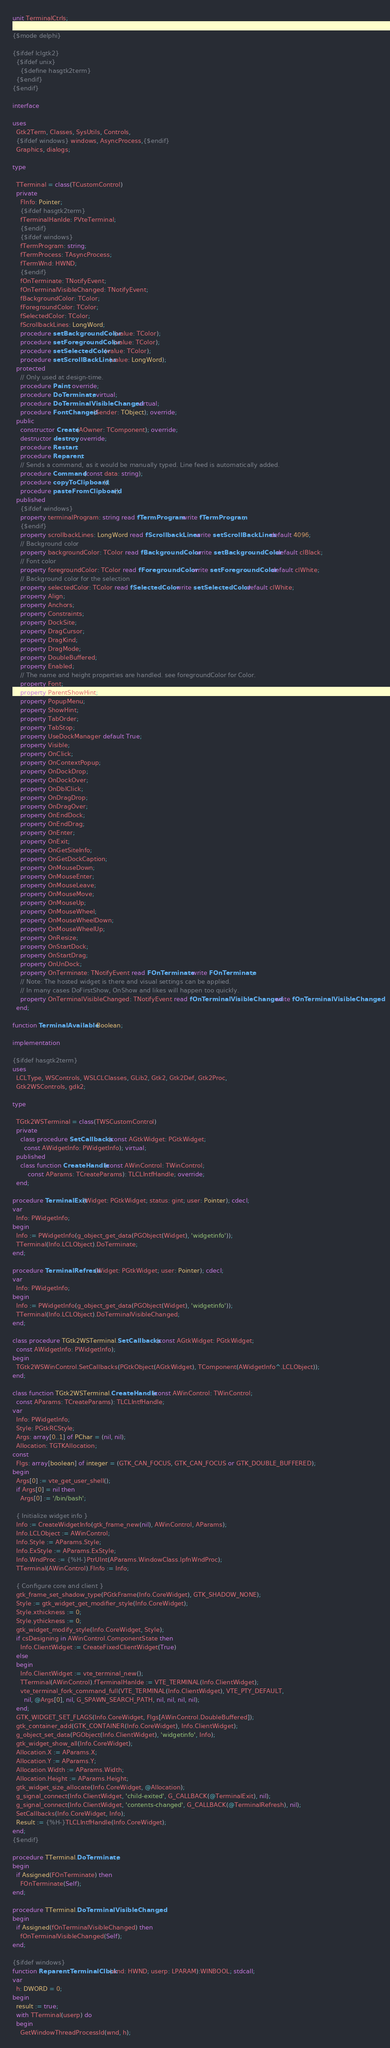Convert code to text. <code><loc_0><loc_0><loc_500><loc_500><_Pascal_>unit TerminalCtrls;

{$mode delphi}

{$ifdef lclgtk2}
  {$ifdef unix}
    {$define hasgtk2term}
  {$endif}
{$endif}

interface

uses
  Gtk2Term, Classes, SysUtils, Controls,
  {$ifdef windows} windows, AsyncProcess,{$endif}
  Graphics, dialogs;

type

  TTerminal = class(TCustomControl)
  private
    FInfo: Pointer;
    {$ifdef hasgtk2term}
    fTerminalHanlde: PVteTerminal;
    {$endif}
    {$ifdef windows}
    fTermProgram: string;
    fTermProcess: TAsyncProcess;
    fTermWnd: HWND;
    {$endif}
    fOnTerminate: TNotifyEvent;
    fOnTerminalVisibleChanged: TNotifyEvent;
    fBackgroundColor: TColor;
    fForegroundColor: TColor;
    fSelectedColor: TColor;
    fScrollbackLines: LongWord;
    procedure setBackgroundColor(value: TColor);
    procedure setForegroundColor(value: TColor);
    procedure setSelectedColor(value: TColor);
    procedure setScrollBackLines(value: LongWord);
  protected
    // Only used at design-time.
    procedure Paint; override;
    procedure DoTerminate; virtual;
    procedure DoTerminalVisibleChanged; virtual;
    procedure FontChanged(Sender: TObject); override;
  public
    constructor Create(AOwner: TComponent); override;
    destructor destroy; override;
    procedure Restart;
    procedure Reparent;
    // Sends a command, as it would be manually typed. Line feed is automatically added.
    procedure Command(const data: string);
    procedure copyToClipboard();
    procedure pasteFromClipboard();
  published
    {$ifdef windows}
    property terminalProgram: string read fTermProgram write fTermProgram;
    {$endif}
    property scrollbackLines: LongWord read fScrollbackLines write setScrollBackLines default 4096;
    // Background color
    property backgroundColor: TColor read fBackgroundColor write setBackgroundColor default clBlack;
    // Font color
    property foregroundColor: TColor read fForegroundColor write setForegroundColor default clWhite;
    // Background color for the selection
    property selectedColor: TColor read fSelectedColor write setSelectedColor default clWhite;
    property Align;
    property Anchors;
    property Constraints;
    property DockSite;
    property DragCursor;
    property DragKind;
    property DragMode;
    property DoubleBuffered;
    property Enabled;
    // The name and height properties are handled. see foregroundColor for Color.
    property Font;
    property ParentShowHint;
    property PopupMenu;
    property ShowHint;
    property TabOrder;
    property TabStop;
    property UseDockManager default True;
    property Visible;
    property OnClick;
    property OnContextPopup;
    property OnDockDrop;
    property OnDockOver;
    property OnDblClick;
    property OnDragDrop;
    property OnDragOver;
    property OnEndDock;
    property OnEndDrag;
    property OnEnter;
    property OnExit;
    property OnGetSiteInfo;
    property OnGetDockCaption;
    property OnMouseDown;
    property OnMouseEnter;
    property OnMouseLeave;
    property OnMouseMove;
    property OnMouseUp;
    property OnMouseWheel;
    property OnMouseWheelDown;
    property OnMouseWheelUp;
    property OnResize;
    property OnStartDock;
    property OnStartDrag;
    property OnUnDock;
    property OnTerminate: TNotifyEvent read FOnTerminate write FOnTerminate;
    // Note: The hosted widget is there and visual settings can be applied.
    // In many cases DoFirstShow, OnShow and likes will happen too quickly.
    property OnTerminalVisibleChanged: TNotifyEvent read fOnTerminalVisibleChanged write fOnTerminalVisibleChanged;
  end;

function TerminalAvailable: Boolean;

implementation

{$ifdef hasgtk2term}
uses
  LCLType, WSControls, WSLCLClasses, GLib2, Gtk2, Gtk2Def, Gtk2Proc,
  Gtk2WSControls, gdk2;

type

  TGtk2WSTerminal = class(TWSCustomControl)
  private
    class procedure SetCallbacks(const AGtkWidget: PGtkWidget;
      const AWidgetInfo: PWidgetInfo); virtual;
  published
    class function CreateHandle(const AWinControl: TWinControl;
        const AParams: TCreateParams): TLCLIntfHandle; override;
  end;

procedure TerminalExit(Widget: PGtkWidget; status: gint; user: Pointer); cdecl;
var
  Info: PWidgetInfo;
begin
  Info := PWidgetInfo(g_object_get_data(PGObject(Widget), 'widgetinfo'));
  TTerminal(Info.LCLObject).DoTerminate;
end;

procedure TerminalRefresh(Widget: PGtkWidget; user: Pointer); cdecl;
var
  Info: PWidgetInfo;
begin
  Info := PWidgetInfo(g_object_get_data(PGObject(Widget), 'widgetinfo'));
  TTerminal(Info.LCLObject).DoTerminalVisibleChanged;
end;

class procedure TGtk2WSTerminal.SetCallbacks(const AGtkWidget: PGtkWidget;
  const AWidgetInfo: PWidgetInfo);
begin
  TGtk2WSWinControl.SetCallbacks(PGtkObject(AGtkWidget), TComponent(AWidgetInfo^.LCLObject));
end;

class function TGtk2WSTerminal.CreateHandle(const AWinControl: TWinControl;
  const AParams: TCreateParams): TLCLIntfHandle;
var
  Info: PWidgetInfo;
  Style: PGtkRCStyle;
  Args: array[0..1] of PChar = (nil, nil);
  Allocation: TGTKAllocation;
const
  Flgs: array[boolean] of integer = (GTK_CAN_FOCUS, GTK_CAN_FOCUS or GTK_DOUBLE_BUFFERED);
begin
  Args[0] := vte_get_user_shell();
  if Args[0] = nil then
    Args[0] := '/bin/bash';

  { Initialize widget info }
  Info := CreateWidgetInfo(gtk_frame_new(nil), AWinControl, AParams);
  Info.LCLObject := AWinControl;
  Info.Style := AParams.Style;
  Info.ExStyle := AParams.ExStyle;
  Info.WndProc := {%H-}PtrUInt(AParams.WindowClass.lpfnWndProc);
  TTerminal(AWinControl).FInfo := Info;

  { Configure core and client }
  gtk_frame_set_shadow_type(PGtkFrame(Info.CoreWidget), GTK_SHADOW_NONE);
  Style := gtk_widget_get_modifier_style(Info.CoreWidget);
  Style.xthickness := 0;
  Style.ythickness := 0;
  gtk_widget_modify_style(Info.CoreWidget, Style);
  if csDesigning in AWinControl.ComponentState then
    Info.ClientWidget := CreateFixedClientWidget(True)
  else
  begin
    Info.ClientWidget := vte_terminal_new();
    TTerminal(AWinControl).fTerminalHanlde := VTE_TERMINAL(Info.ClientWidget);
    vte_terminal_fork_command_full(VTE_TERMINAL(Info.ClientWidget), VTE_PTY_DEFAULT,
      nil, @Args[0], nil, G_SPAWN_SEARCH_PATH, nil, nil, nil, nil);
  end;
  GTK_WIDGET_SET_FLAGS(Info.CoreWidget, Flgs[AWinControl.DoubleBuffered]);
  gtk_container_add(GTK_CONTAINER(Info.CoreWidget), Info.ClientWidget);
  g_object_set_data(PGObject(Info.ClientWidget), 'widgetinfo', Info);
  gtk_widget_show_all(Info.CoreWidget);
  Allocation.X := AParams.X;
  Allocation.Y := AParams.Y;
  Allocation.Width := AParams.Width;
  Allocation.Height := AParams.Height;
  gtk_widget_size_allocate(Info.CoreWidget, @Allocation);
  g_signal_connect(Info.ClientWidget, 'child-exited', G_CALLBACK(@TerminalExit), nil);
  g_signal_connect(Info.ClientWidget, 'contents-changed', G_CALLBACK(@TerminalRefresh), nil);
  SetCallbacks(Info.CoreWidget, Info);
  Result := {%H-}TLCLIntfHandle(Info.CoreWidget);
end;
{$endif}

procedure TTerminal.DoTerminate;
begin
  if Assigned(FOnTerminate) then
    FOnTerminate(Self);
end;

procedure TTerminal.DoTerminalVisibleChanged;
begin
  if Assigned(fOnTerminalVisibleChanged) then
    fOnTerminalVisibleChanged(Self);
end;

{$ifdef windows}
function ReparentTerminalClbck(wnd: HWND; userp: LPARAM):WINBOOL; stdcall;
var
  h: DWORD = 0;
begin
  result := true;
  with TTerminal(userp) do
  begin
    GetWindowThreadProcessId(wnd, h);</code> 